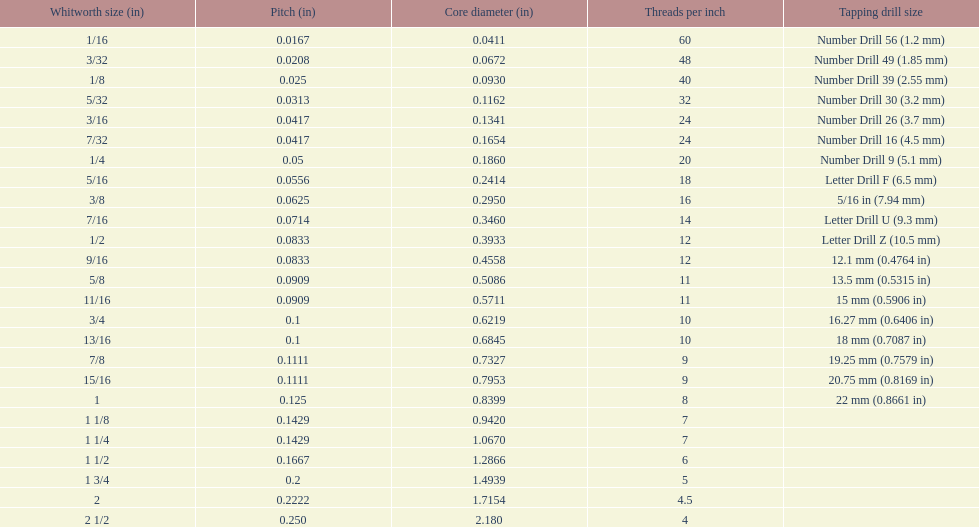What is the top amount of threads per inch? 60. 